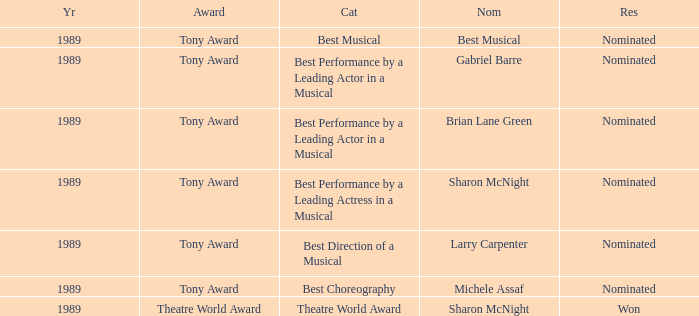What was the nominee of best musical Best Musical. 